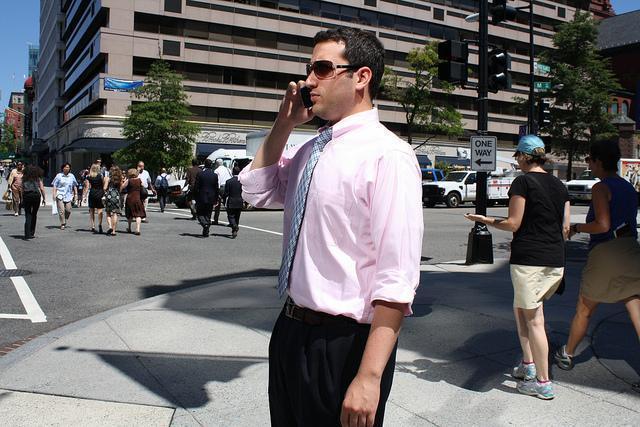How many people are there?
Give a very brief answer. 4. How many cats are facing away?
Give a very brief answer. 0. 